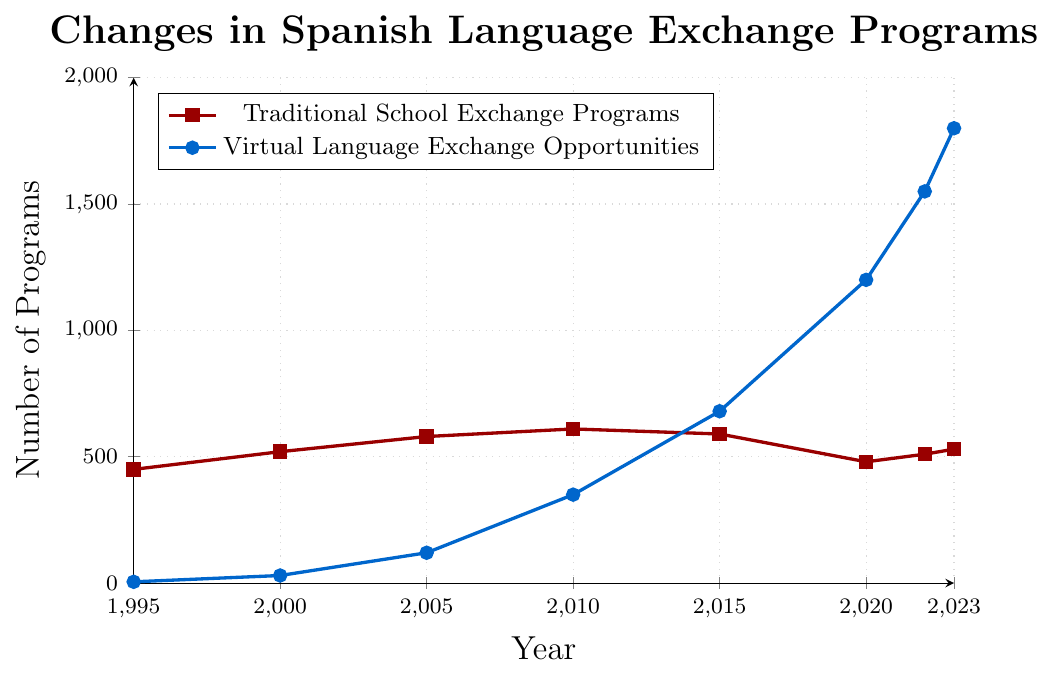Which type of exchange program experiences more significant growth overall from 1995 to the present? Comparing the increase from 1995 to 2023, traditional programs grow from 450 to 530, whereas virtual programs grow from 5 to 1800. The growth for virtual programs is more significant.
Answer: Virtual programs When was the number of traditional school exchange programs highest? By observing the line chart, the highest point for traditional programs is in 2010 with 610 programs.
Answer: 2010 What is the difference in the number of virtual language exchange opportunities between 2020 and 2023? The number of virtual opportunities in 2020 is 1200, and in 2023 it's 1800. The difference is 1800 - 1200 = 600.
Answer: 600 What trend do you observe in the number of traditional school exchange programs from 2010 to 2020? From 2010 (610 programs), there's a downward trend to 2020 (480 programs), indicating a decline.
Answer: Decline Compare the numbers of traditional and virtual language exchange programs in 2005. In 2005, traditional programs are 580, whereas virtual programs are 120. Traditional programs are higher.
Answer: Traditional programs are higher Which year marks the first time that virtual language exchange opportunities surpass 1000 programs? Referring to the data points, virtual programs surpass 1000 in 2020.
Answer: 2020 By how much did the number of virtual language exchange opportunities grow from 1995 to 2000? The number of virtual programs is 5 in 1995 and 30 in 2000, growing by 30 - 5 = 25.
Answer: 25 What is the average number of traditional school exchange programs from 1995 to 2023? Summing the values for traditional programs ((450 + 520 + 580 + 610 + 590 + 480 + 510 + 530) = 4270) and dividing by the number of years (8) gives an average of 4270 / 8 = 533.75.
Answer: 533.75 Do traditional school exchange programs ever increase after 2015? They decrease from 2015 (590) to 2020 (480), but then increase again from 2020 (480) to 2023 (530).
Answer: Yes 